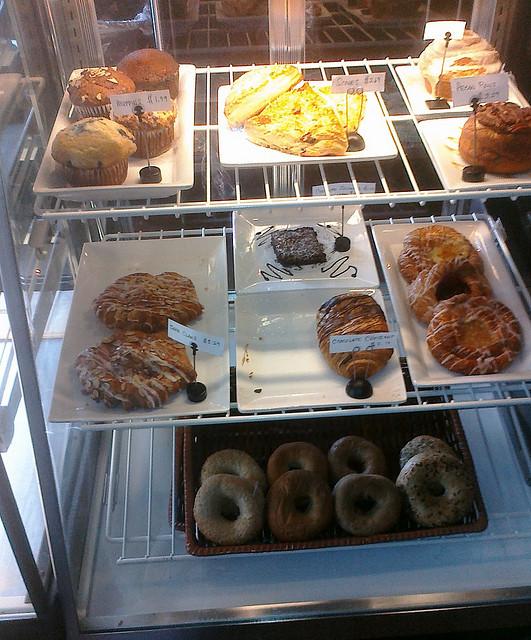Is this food sweet?
Give a very brief answer. Yes. What is the calorie level of all of these donuts?
Answer briefly. High. What are these called?
Keep it brief. Pastries. 